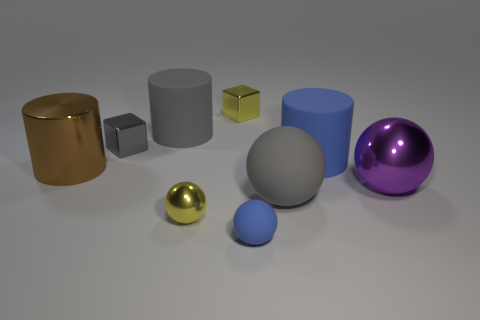Add 1 tiny yellow metallic blocks. How many objects exist? 10 Subtract all cylinders. How many objects are left? 6 Subtract all large brown objects. Subtract all blue cylinders. How many objects are left? 7 Add 5 large gray balls. How many large gray balls are left? 6 Add 6 gray metallic things. How many gray metallic things exist? 7 Subtract 1 purple balls. How many objects are left? 8 